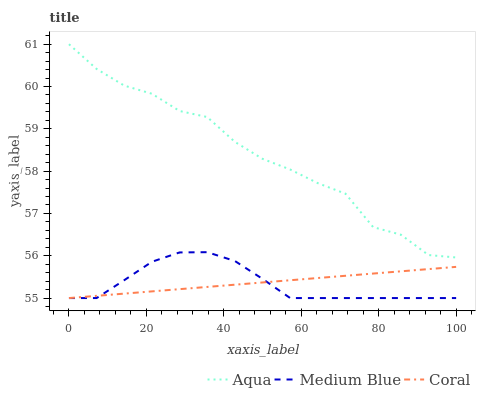Does Coral have the minimum area under the curve?
Answer yes or no. No. Does Coral have the maximum area under the curve?
Answer yes or no. No. Is Aqua the smoothest?
Answer yes or no. No. Is Coral the roughest?
Answer yes or no. No. Does Aqua have the lowest value?
Answer yes or no. No. Does Coral have the highest value?
Answer yes or no. No. Is Medium Blue less than Aqua?
Answer yes or no. Yes. Is Aqua greater than Coral?
Answer yes or no. Yes. Does Medium Blue intersect Aqua?
Answer yes or no. No. 